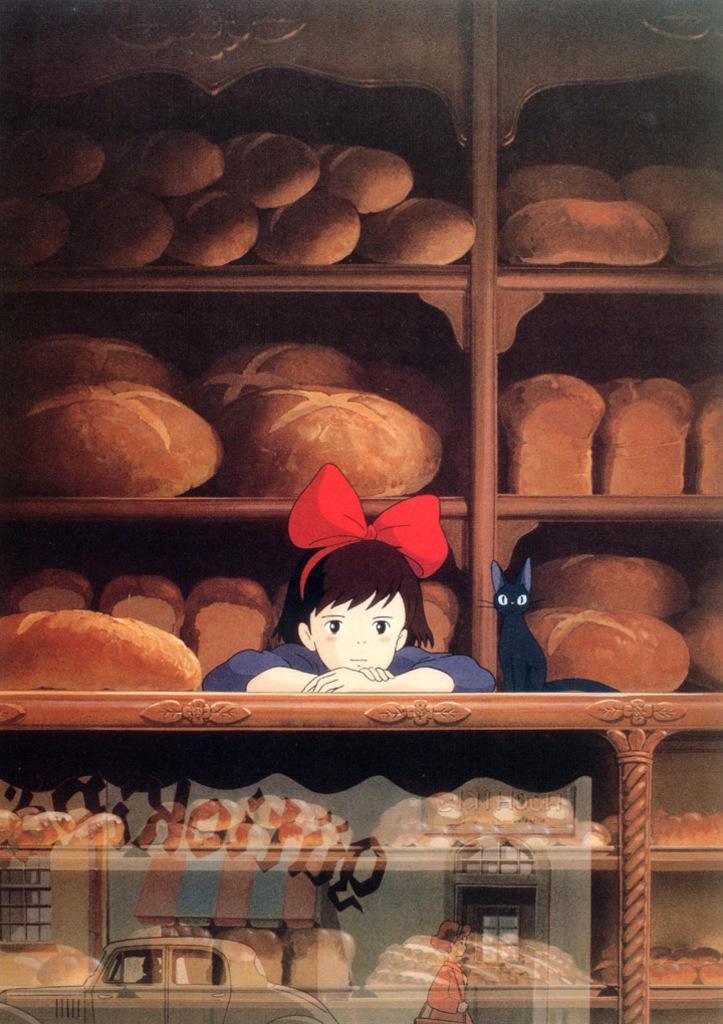In one or two sentences, can you explain what this image depicts? In this image I can see a cartoon girl and cat. They are in different color. Back I can see brown color objects on the rack. Front I can see car and a person. 